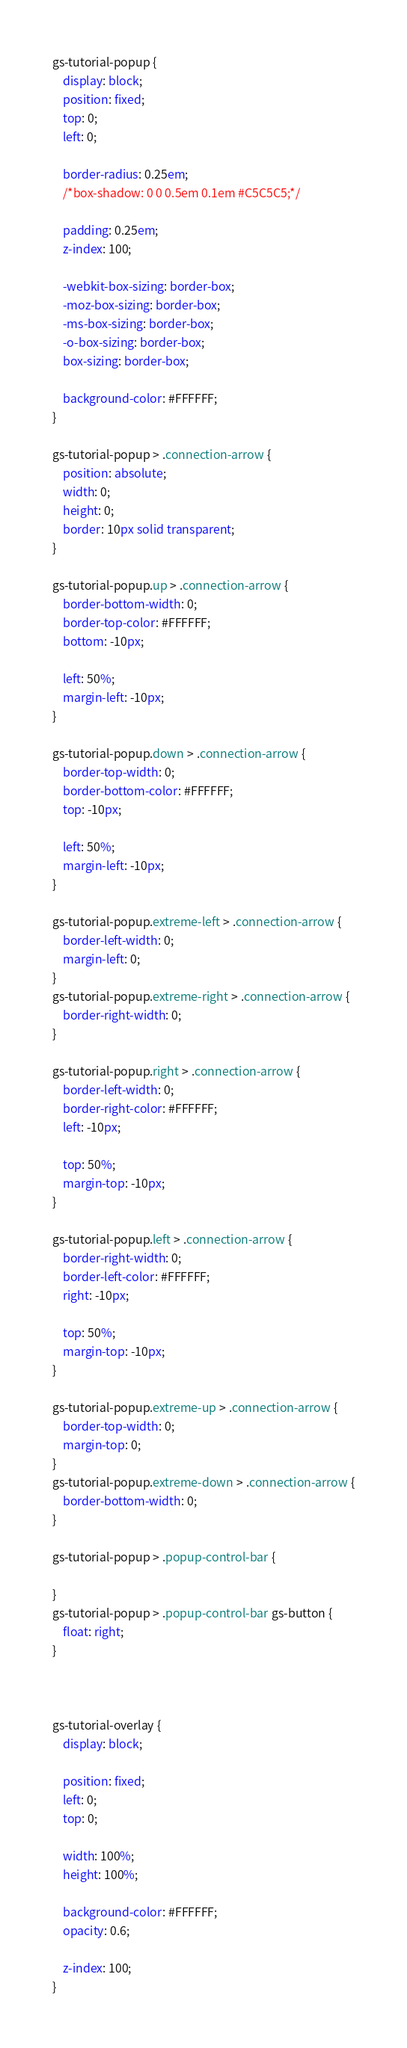Convert code to text. <code><loc_0><loc_0><loc_500><loc_500><_CSS_>

gs-tutorial-popup {
    display: block;
    position: fixed;
    top: 0;
    left: 0;
    
    border-radius: 0.25em;
    /*box-shadow: 0 0 0.5em 0.1em #C5C5C5;*/
    
    padding: 0.25em;
    z-index: 100;
    
    -webkit-box-sizing: border-box;
    -moz-box-sizing: border-box;
    -ms-box-sizing: border-box;
    -o-box-sizing: border-box;
    box-sizing: border-box;
    
    background-color: #FFFFFF;
}

gs-tutorial-popup > .connection-arrow {
    position: absolute;
	width: 0;
	height: 0;
	border: 10px solid transparent;
}

gs-tutorial-popup.up > .connection-arrow {
	border-bottom-width: 0;
	border-top-color: #FFFFFF;
	bottom: -10px;
    
    left: 50%;
    margin-left: -10px;
}

gs-tutorial-popup.down > .connection-arrow {
	border-top-width: 0;
	border-bottom-color: #FFFFFF;
    top: -10px;
	
    left: 50%;
    margin-left: -10px;
}

gs-tutorial-popup.extreme-left > .connection-arrow {
	border-left-width: 0;
    margin-left: 0;
}
gs-tutorial-popup.extreme-right > .connection-arrow {
	border-right-width: 0;
}

gs-tutorial-popup.right > .connection-arrow {
	border-left-width: 0;
	border-right-color: #FFFFFF;
    left: -10px;
    
    top: 50%;
    margin-top: -10px;
}

gs-tutorial-popup.left > .connection-arrow {
	border-right-width: 0;
	border-left-color: #FFFFFF;
    right: -10px;
    
    top: 50%;
    margin-top: -10px;
}

gs-tutorial-popup.extreme-up > .connection-arrow {
	border-top-width: 0;
    margin-top: 0;
}
gs-tutorial-popup.extreme-down > .connection-arrow {
	border-bottom-width: 0;
}

gs-tutorial-popup > .popup-control-bar {
    
}
gs-tutorial-popup > .popup-control-bar gs-button {
	float: right;
}



gs-tutorial-overlay {
    display: block;
    
    position: fixed;
    left: 0;
    top: 0;
    
    width: 100%;
    height: 100%;
    
    background-color: #FFFFFF;
    opacity: 0.6;
    
    z-index: 100;
}</code> 